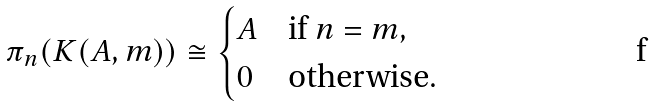<formula> <loc_0><loc_0><loc_500><loc_500>\pi _ { n } ( K ( A , m ) ) \cong \begin{cases} A & \text {if } n = m , \\ 0 & \text {otherwise} . \end{cases}</formula> 